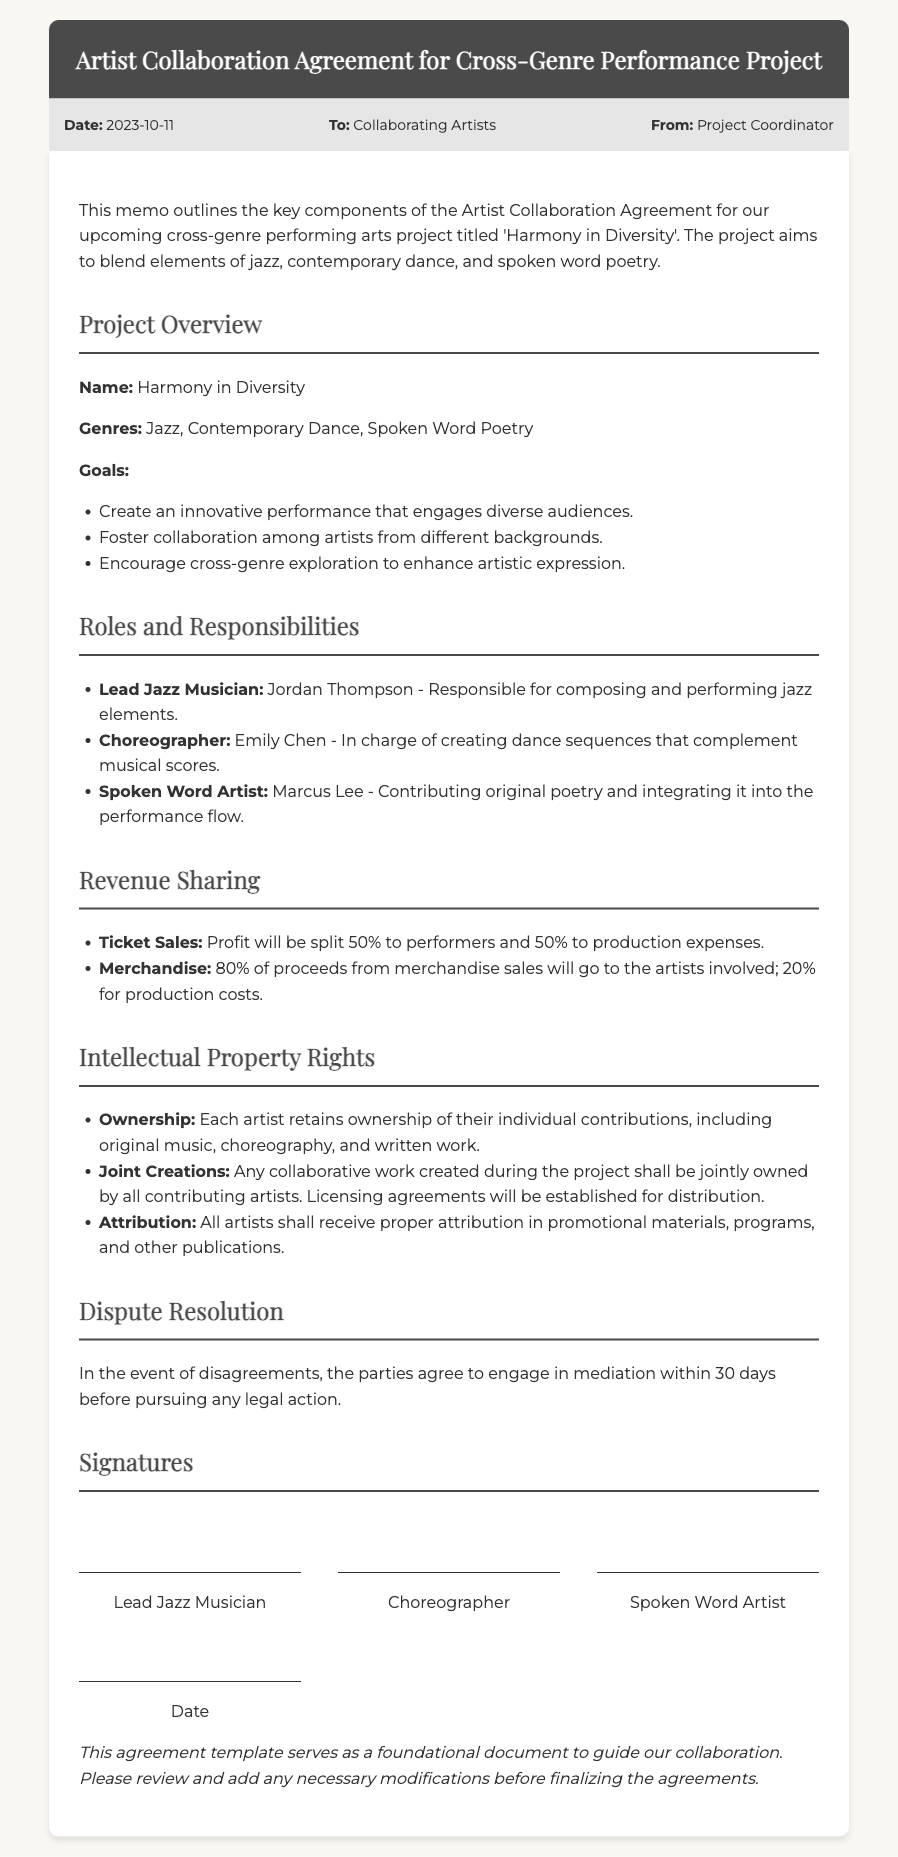What is the name of the project? The document specifies the name of the project as 'Harmony in Diversity'.
Answer: Harmony in Diversity Who is responsible for composing jazz elements? The lead jazz musician responsible for composing and performing jazz elements is Jordan Thompson.
Answer: Jordan Thompson What percentage of merchandise proceeds goes to artists? The document states that 80% of proceeds from merchandise sales will go to the artists involved.
Answer: 80% What is the resolution time frame for disputes? The memo indicates that the parties agree to engage in mediation within 30 days before pursuing any legal action.
Answer: 30 days What role does Emily Chen have in the project? Emily Chen is designated as the choreographer, responsible for creating dance sequences.
Answer: Choreographer How are ticket sale profits shared? According to the memo, profits from ticket sales will be split 50% to performers and 50% to production expenses.
Answer: 50% What is the ownership status of individual contributions? Each artist retains ownership of their individual contributions, including original music, choreography, and written work.
Answer: Each artist retains ownership Who contributes original poetry to the performance? The spoken word artist responsible for contributing original poetry is Marcus Lee.
Answer: Marcus Lee What type of artistic expression is encouraged by the project? The project encourages cross-genre exploration to enhance artistic expression.
Answer: Cross-genre exploration 